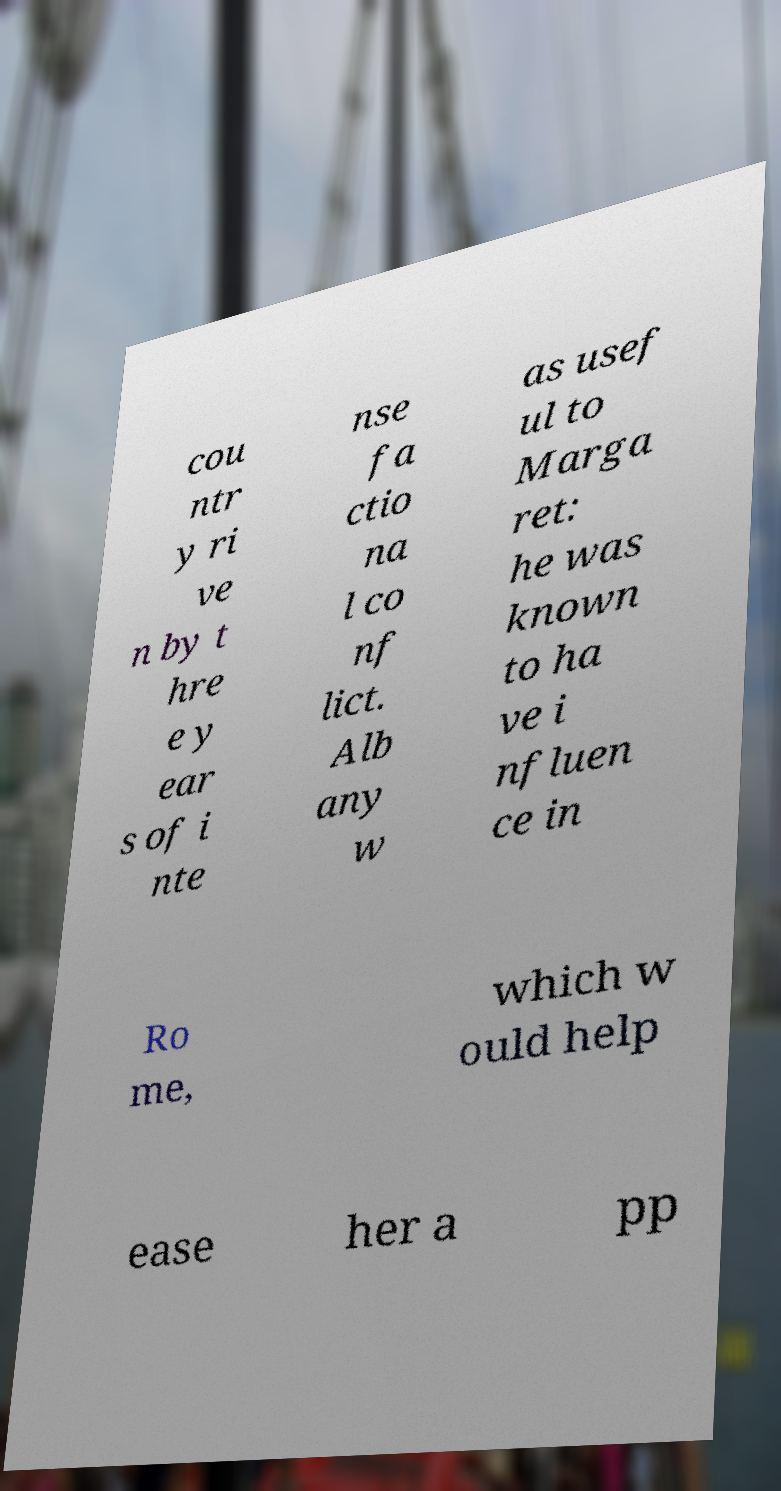Could you extract and type out the text from this image? cou ntr y ri ve n by t hre e y ear s of i nte nse fa ctio na l co nf lict. Alb any w as usef ul to Marga ret: he was known to ha ve i nfluen ce in Ro me, which w ould help ease her a pp 